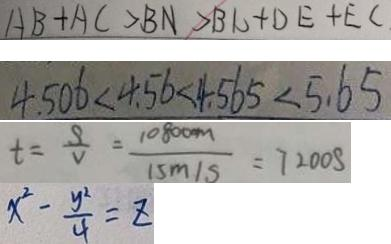<formula> <loc_0><loc_0><loc_500><loc_500>A B + A C > B N > B C + D E + E C 
 4 . 5 0 6 < 4 . 5 6 < 4 . 5 6 5 < 5 . 6 5 
 t = \frac { S } { V } = \frac { 1 0 8 0 0 m } { 1 5 m / s } = 7 2 0 0 S 
 x ^ { 2 } - \frac { y ^ { 2 } } { 4 } = z</formula> 